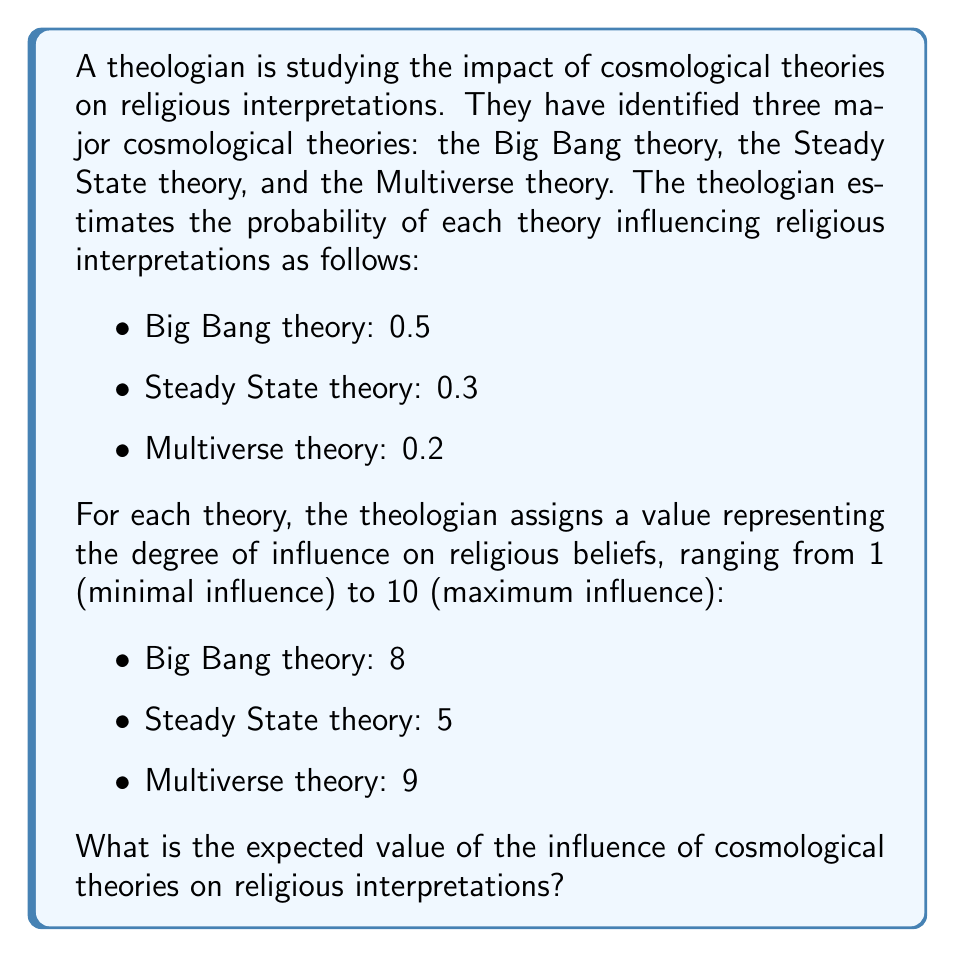Provide a solution to this math problem. To solve this problem, we need to calculate the expected value using the given probabilities and influence values for each cosmological theory. The expected value is the sum of each outcome multiplied by its probability.

Let's follow these steps:

1. Identify the probability (P) and value (V) for each theory:
   - Big Bang theory: $P_{BB} = 0.5$, $V_{BB} = 8$
   - Steady State theory: $P_{SS} = 0.3$, $V_{SS} = 5$
   - Multiverse theory: $P_{MV} = 0.2$, $V_{MV} = 9$

2. Calculate the contribution of each theory to the expected value:
   - Big Bang theory: $E_{BB} = P_{BB} \times V_{BB} = 0.5 \times 8 = 4$
   - Steady State theory: $E_{SS} = P_{SS} \times V_{SS} = 0.3 \times 5 = 1.5$
   - Multiverse theory: $E_{MV} = P_{MV} \times V_{MV} = 0.2 \times 9 = 1.8$

3. Sum up the individual contributions to get the total expected value:

   $$E = E_{BB} + E_{SS} + E_{MV}$$
   $$E = 4 + 1.5 + 1.8 = 7.3$$

Therefore, the expected value of the influence of cosmological theories on religious interpretations is 7.3.
Answer: 7.3 